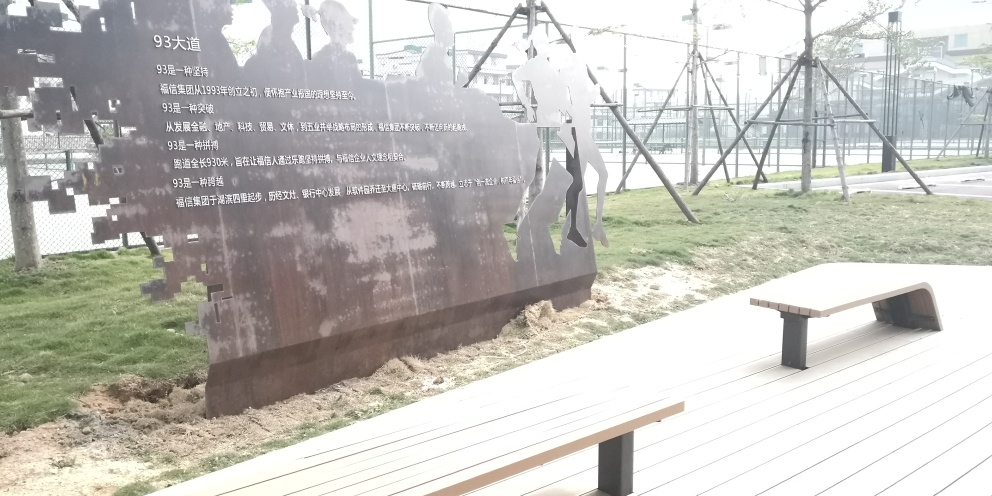Can you tell us more about the text on the metal structure? The text on the metal structure is not entirely clear from the photograph, but it appears to be in Chinese. Based on the context of the art installation, it may contain information pertaining to the purpose or theme of the exhibit, such as historical dates, names, or an artist's statement. To fully understand the text's meaning, a closer, clearer image or translation would be necessary. 